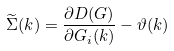<formula> <loc_0><loc_0><loc_500><loc_500>\widetilde { \Sigma } ( { k } ) = \frac { \partial D ( G ) } { \partial G _ { i } ( { k } ) } - \vartheta ( { k } )</formula> 